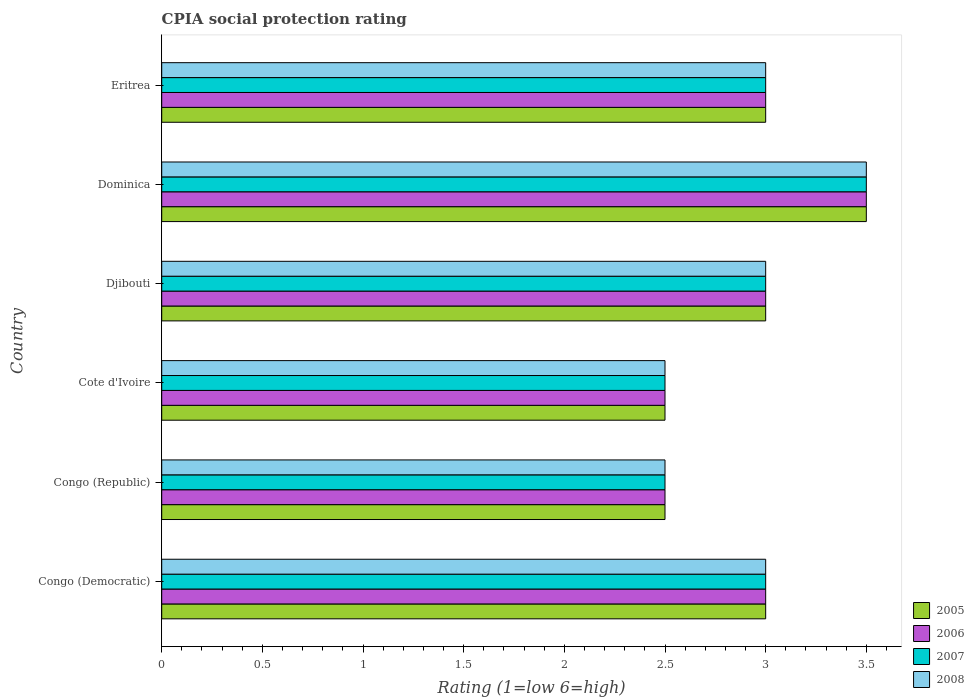How many different coloured bars are there?
Offer a terse response. 4. How many groups of bars are there?
Provide a short and direct response. 6. How many bars are there on the 1st tick from the top?
Your answer should be compact. 4. What is the label of the 1st group of bars from the top?
Provide a succinct answer. Eritrea. Across all countries, what is the maximum CPIA rating in 2008?
Offer a very short reply. 3.5. In which country was the CPIA rating in 2006 maximum?
Provide a short and direct response. Dominica. In which country was the CPIA rating in 2006 minimum?
Offer a very short reply. Congo (Republic). What is the total CPIA rating in 2005 in the graph?
Keep it short and to the point. 17.5. What is the difference between the CPIA rating in 2007 in Cote d'Ivoire and that in Eritrea?
Offer a very short reply. -0.5. What is the difference between the CPIA rating in 2006 in Dominica and the CPIA rating in 2008 in Congo (Republic)?
Keep it short and to the point. 1. What is the average CPIA rating in 2008 per country?
Provide a short and direct response. 2.92. What is the ratio of the CPIA rating in 2008 in Cote d'Ivoire to that in Djibouti?
Offer a terse response. 0.83. Is the CPIA rating in 2005 in Congo (Democratic) less than that in Cote d'Ivoire?
Give a very brief answer. No. What is the difference between the highest and the second highest CPIA rating in 2006?
Make the answer very short. 0.5. What is the difference between the highest and the lowest CPIA rating in 2006?
Your response must be concise. 1. In how many countries, is the CPIA rating in 2006 greater than the average CPIA rating in 2006 taken over all countries?
Your answer should be compact. 4. Is the sum of the CPIA rating in 2007 in Congo (Republic) and Eritrea greater than the maximum CPIA rating in 2006 across all countries?
Provide a succinct answer. Yes. What does the 1st bar from the top in Djibouti represents?
Provide a short and direct response. 2008. What does the 4th bar from the bottom in Cote d'Ivoire represents?
Keep it short and to the point. 2008. Is it the case that in every country, the sum of the CPIA rating in 2007 and CPIA rating in 2008 is greater than the CPIA rating in 2005?
Give a very brief answer. Yes. Are all the bars in the graph horizontal?
Provide a short and direct response. Yes. How many countries are there in the graph?
Offer a very short reply. 6. What is the difference between two consecutive major ticks on the X-axis?
Give a very brief answer. 0.5. Are the values on the major ticks of X-axis written in scientific E-notation?
Make the answer very short. No. Does the graph contain any zero values?
Provide a succinct answer. No. What is the title of the graph?
Give a very brief answer. CPIA social protection rating. What is the label or title of the X-axis?
Keep it short and to the point. Rating (1=low 6=high). What is the Rating (1=low 6=high) of 2006 in Congo (Democratic)?
Offer a terse response. 3. What is the Rating (1=low 6=high) in 2005 in Congo (Republic)?
Ensure brevity in your answer.  2.5. What is the Rating (1=low 6=high) of 2005 in Cote d'Ivoire?
Provide a short and direct response. 2.5. What is the Rating (1=low 6=high) of 2006 in Cote d'Ivoire?
Keep it short and to the point. 2.5. What is the Rating (1=low 6=high) of 2008 in Cote d'Ivoire?
Your response must be concise. 2.5. What is the Rating (1=low 6=high) in 2006 in Djibouti?
Give a very brief answer. 3. What is the Rating (1=low 6=high) in 2005 in Dominica?
Give a very brief answer. 3.5. What is the Rating (1=low 6=high) in 2008 in Dominica?
Provide a succinct answer. 3.5. What is the Rating (1=low 6=high) of 2006 in Eritrea?
Give a very brief answer. 3. What is the Rating (1=low 6=high) of 2007 in Eritrea?
Provide a short and direct response. 3. What is the Rating (1=low 6=high) in 2008 in Eritrea?
Ensure brevity in your answer.  3. Across all countries, what is the maximum Rating (1=low 6=high) of 2005?
Provide a succinct answer. 3.5. Across all countries, what is the maximum Rating (1=low 6=high) of 2006?
Offer a very short reply. 3.5. Across all countries, what is the maximum Rating (1=low 6=high) in 2007?
Keep it short and to the point. 3.5. Across all countries, what is the minimum Rating (1=low 6=high) of 2007?
Provide a succinct answer. 2.5. Across all countries, what is the minimum Rating (1=low 6=high) in 2008?
Offer a very short reply. 2.5. What is the total Rating (1=low 6=high) of 2005 in the graph?
Give a very brief answer. 17.5. What is the total Rating (1=low 6=high) in 2006 in the graph?
Keep it short and to the point. 17.5. What is the total Rating (1=low 6=high) in 2007 in the graph?
Provide a succinct answer. 17.5. What is the total Rating (1=low 6=high) of 2008 in the graph?
Give a very brief answer. 17.5. What is the difference between the Rating (1=low 6=high) in 2005 in Congo (Democratic) and that in Congo (Republic)?
Your answer should be very brief. 0.5. What is the difference between the Rating (1=low 6=high) in 2007 in Congo (Democratic) and that in Congo (Republic)?
Provide a succinct answer. 0.5. What is the difference between the Rating (1=low 6=high) in 2005 in Congo (Democratic) and that in Cote d'Ivoire?
Your answer should be compact. 0.5. What is the difference between the Rating (1=low 6=high) of 2006 in Congo (Democratic) and that in Djibouti?
Give a very brief answer. 0. What is the difference between the Rating (1=low 6=high) of 2007 in Congo (Democratic) and that in Djibouti?
Offer a terse response. 0. What is the difference between the Rating (1=low 6=high) of 2008 in Congo (Democratic) and that in Djibouti?
Provide a succinct answer. 0. What is the difference between the Rating (1=low 6=high) in 2005 in Congo (Democratic) and that in Dominica?
Ensure brevity in your answer.  -0.5. What is the difference between the Rating (1=low 6=high) of 2007 in Congo (Democratic) and that in Dominica?
Make the answer very short. -0.5. What is the difference between the Rating (1=low 6=high) in 2008 in Congo (Democratic) and that in Dominica?
Offer a very short reply. -0.5. What is the difference between the Rating (1=low 6=high) in 2008 in Congo (Democratic) and that in Eritrea?
Keep it short and to the point. 0. What is the difference between the Rating (1=low 6=high) of 2005 in Congo (Republic) and that in Cote d'Ivoire?
Provide a succinct answer. 0. What is the difference between the Rating (1=low 6=high) of 2007 in Congo (Republic) and that in Cote d'Ivoire?
Offer a terse response. 0. What is the difference between the Rating (1=low 6=high) in 2008 in Congo (Republic) and that in Cote d'Ivoire?
Provide a succinct answer. 0. What is the difference between the Rating (1=low 6=high) of 2005 in Congo (Republic) and that in Djibouti?
Your response must be concise. -0.5. What is the difference between the Rating (1=low 6=high) in 2006 in Congo (Republic) and that in Djibouti?
Your answer should be very brief. -0.5. What is the difference between the Rating (1=low 6=high) in 2007 in Congo (Republic) and that in Djibouti?
Make the answer very short. -0.5. What is the difference between the Rating (1=low 6=high) of 2008 in Congo (Republic) and that in Djibouti?
Offer a terse response. -0.5. What is the difference between the Rating (1=low 6=high) in 2006 in Congo (Republic) and that in Dominica?
Make the answer very short. -1. What is the difference between the Rating (1=low 6=high) of 2008 in Congo (Republic) and that in Dominica?
Provide a succinct answer. -1. What is the difference between the Rating (1=low 6=high) in 2006 in Congo (Republic) and that in Eritrea?
Ensure brevity in your answer.  -0.5. What is the difference between the Rating (1=low 6=high) of 2007 in Congo (Republic) and that in Eritrea?
Offer a very short reply. -0.5. What is the difference between the Rating (1=low 6=high) in 2008 in Congo (Republic) and that in Eritrea?
Your response must be concise. -0.5. What is the difference between the Rating (1=low 6=high) in 2005 in Cote d'Ivoire and that in Djibouti?
Keep it short and to the point. -0.5. What is the difference between the Rating (1=low 6=high) of 2008 in Cote d'Ivoire and that in Djibouti?
Offer a terse response. -0.5. What is the difference between the Rating (1=low 6=high) of 2007 in Cote d'Ivoire and that in Dominica?
Your response must be concise. -1. What is the difference between the Rating (1=low 6=high) of 2008 in Cote d'Ivoire and that in Dominica?
Your answer should be compact. -1. What is the difference between the Rating (1=low 6=high) of 2005 in Djibouti and that in Dominica?
Offer a terse response. -0.5. What is the difference between the Rating (1=low 6=high) in 2006 in Djibouti and that in Dominica?
Provide a short and direct response. -0.5. What is the difference between the Rating (1=low 6=high) in 2007 in Djibouti and that in Dominica?
Offer a terse response. -0.5. What is the difference between the Rating (1=low 6=high) in 2005 in Djibouti and that in Eritrea?
Provide a short and direct response. 0. What is the difference between the Rating (1=low 6=high) of 2006 in Djibouti and that in Eritrea?
Give a very brief answer. 0. What is the difference between the Rating (1=low 6=high) in 2007 in Djibouti and that in Eritrea?
Your response must be concise. 0. What is the difference between the Rating (1=low 6=high) of 2008 in Djibouti and that in Eritrea?
Your answer should be very brief. 0. What is the difference between the Rating (1=low 6=high) of 2005 in Dominica and that in Eritrea?
Your answer should be very brief. 0.5. What is the difference between the Rating (1=low 6=high) in 2006 in Dominica and that in Eritrea?
Ensure brevity in your answer.  0.5. What is the difference between the Rating (1=low 6=high) in 2007 in Dominica and that in Eritrea?
Ensure brevity in your answer.  0.5. What is the difference between the Rating (1=low 6=high) of 2005 in Congo (Democratic) and the Rating (1=low 6=high) of 2006 in Congo (Republic)?
Ensure brevity in your answer.  0.5. What is the difference between the Rating (1=low 6=high) of 2005 in Congo (Democratic) and the Rating (1=low 6=high) of 2007 in Congo (Republic)?
Ensure brevity in your answer.  0.5. What is the difference between the Rating (1=low 6=high) of 2005 in Congo (Democratic) and the Rating (1=low 6=high) of 2008 in Congo (Republic)?
Offer a very short reply. 0.5. What is the difference between the Rating (1=low 6=high) in 2006 in Congo (Democratic) and the Rating (1=low 6=high) in 2008 in Congo (Republic)?
Provide a short and direct response. 0.5. What is the difference between the Rating (1=low 6=high) of 2007 in Congo (Democratic) and the Rating (1=low 6=high) of 2008 in Congo (Republic)?
Make the answer very short. 0.5. What is the difference between the Rating (1=low 6=high) of 2005 in Congo (Democratic) and the Rating (1=low 6=high) of 2007 in Cote d'Ivoire?
Your answer should be very brief. 0.5. What is the difference between the Rating (1=low 6=high) in 2005 in Congo (Democratic) and the Rating (1=low 6=high) in 2008 in Cote d'Ivoire?
Offer a terse response. 0.5. What is the difference between the Rating (1=low 6=high) in 2006 in Congo (Democratic) and the Rating (1=low 6=high) in 2007 in Cote d'Ivoire?
Your answer should be compact. 0.5. What is the difference between the Rating (1=low 6=high) in 2006 in Congo (Democratic) and the Rating (1=low 6=high) in 2008 in Cote d'Ivoire?
Your answer should be very brief. 0.5. What is the difference between the Rating (1=low 6=high) of 2005 in Congo (Democratic) and the Rating (1=low 6=high) of 2006 in Djibouti?
Keep it short and to the point. 0. What is the difference between the Rating (1=low 6=high) in 2005 in Congo (Democratic) and the Rating (1=low 6=high) in 2007 in Djibouti?
Your answer should be very brief. 0. What is the difference between the Rating (1=low 6=high) in 2006 in Congo (Democratic) and the Rating (1=low 6=high) in 2007 in Djibouti?
Provide a succinct answer. 0. What is the difference between the Rating (1=low 6=high) in 2007 in Congo (Democratic) and the Rating (1=low 6=high) in 2008 in Dominica?
Provide a short and direct response. -0.5. What is the difference between the Rating (1=low 6=high) of 2005 in Congo (Democratic) and the Rating (1=low 6=high) of 2007 in Eritrea?
Your response must be concise. 0. What is the difference between the Rating (1=low 6=high) of 2005 in Congo (Republic) and the Rating (1=low 6=high) of 2007 in Cote d'Ivoire?
Ensure brevity in your answer.  0. What is the difference between the Rating (1=low 6=high) of 2006 in Congo (Republic) and the Rating (1=low 6=high) of 2007 in Cote d'Ivoire?
Keep it short and to the point. 0. What is the difference between the Rating (1=low 6=high) of 2006 in Congo (Republic) and the Rating (1=low 6=high) of 2008 in Cote d'Ivoire?
Offer a terse response. 0. What is the difference between the Rating (1=low 6=high) in 2005 in Congo (Republic) and the Rating (1=low 6=high) in 2006 in Djibouti?
Your answer should be very brief. -0.5. What is the difference between the Rating (1=low 6=high) in 2005 in Congo (Republic) and the Rating (1=low 6=high) in 2007 in Djibouti?
Offer a terse response. -0.5. What is the difference between the Rating (1=low 6=high) in 2006 in Congo (Republic) and the Rating (1=low 6=high) in 2008 in Djibouti?
Provide a succinct answer. -0.5. What is the difference between the Rating (1=low 6=high) of 2005 in Congo (Republic) and the Rating (1=low 6=high) of 2006 in Dominica?
Ensure brevity in your answer.  -1. What is the difference between the Rating (1=low 6=high) in 2005 in Congo (Republic) and the Rating (1=low 6=high) in 2007 in Dominica?
Provide a short and direct response. -1. What is the difference between the Rating (1=low 6=high) in 2005 in Congo (Republic) and the Rating (1=low 6=high) in 2008 in Dominica?
Provide a succinct answer. -1. What is the difference between the Rating (1=low 6=high) in 2006 in Congo (Republic) and the Rating (1=low 6=high) in 2007 in Dominica?
Your answer should be compact. -1. What is the difference between the Rating (1=low 6=high) in 2006 in Congo (Republic) and the Rating (1=low 6=high) in 2008 in Dominica?
Provide a short and direct response. -1. What is the difference between the Rating (1=low 6=high) of 2007 in Congo (Republic) and the Rating (1=low 6=high) of 2008 in Dominica?
Your answer should be very brief. -1. What is the difference between the Rating (1=low 6=high) of 2005 in Congo (Republic) and the Rating (1=low 6=high) of 2006 in Eritrea?
Your response must be concise. -0.5. What is the difference between the Rating (1=low 6=high) in 2005 in Congo (Republic) and the Rating (1=low 6=high) in 2008 in Eritrea?
Give a very brief answer. -0.5. What is the difference between the Rating (1=low 6=high) of 2006 in Congo (Republic) and the Rating (1=low 6=high) of 2008 in Eritrea?
Ensure brevity in your answer.  -0.5. What is the difference between the Rating (1=low 6=high) of 2007 in Congo (Republic) and the Rating (1=low 6=high) of 2008 in Eritrea?
Provide a short and direct response. -0.5. What is the difference between the Rating (1=low 6=high) in 2005 in Cote d'Ivoire and the Rating (1=low 6=high) in 2007 in Djibouti?
Your answer should be compact. -0.5. What is the difference between the Rating (1=low 6=high) of 2007 in Cote d'Ivoire and the Rating (1=low 6=high) of 2008 in Djibouti?
Your answer should be very brief. -0.5. What is the difference between the Rating (1=low 6=high) of 2005 in Cote d'Ivoire and the Rating (1=low 6=high) of 2006 in Dominica?
Provide a short and direct response. -1. What is the difference between the Rating (1=low 6=high) in 2005 in Cote d'Ivoire and the Rating (1=low 6=high) in 2007 in Dominica?
Offer a very short reply. -1. What is the difference between the Rating (1=low 6=high) of 2006 in Cote d'Ivoire and the Rating (1=low 6=high) of 2007 in Dominica?
Offer a terse response. -1. What is the difference between the Rating (1=low 6=high) in 2006 in Cote d'Ivoire and the Rating (1=low 6=high) in 2008 in Dominica?
Provide a succinct answer. -1. What is the difference between the Rating (1=low 6=high) in 2005 in Cote d'Ivoire and the Rating (1=low 6=high) in 2006 in Eritrea?
Your answer should be compact. -0.5. What is the difference between the Rating (1=low 6=high) of 2005 in Cote d'Ivoire and the Rating (1=low 6=high) of 2007 in Eritrea?
Provide a succinct answer. -0.5. What is the difference between the Rating (1=low 6=high) of 2006 in Cote d'Ivoire and the Rating (1=low 6=high) of 2007 in Eritrea?
Your answer should be very brief. -0.5. What is the difference between the Rating (1=low 6=high) in 2006 in Cote d'Ivoire and the Rating (1=low 6=high) in 2008 in Eritrea?
Your answer should be very brief. -0.5. What is the difference between the Rating (1=low 6=high) in 2005 in Djibouti and the Rating (1=low 6=high) in 2006 in Dominica?
Keep it short and to the point. -0.5. What is the difference between the Rating (1=low 6=high) in 2006 in Djibouti and the Rating (1=low 6=high) in 2007 in Dominica?
Your response must be concise. -0.5. What is the difference between the Rating (1=low 6=high) in 2005 in Djibouti and the Rating (1=low 6=high) in 2006 in Eritrea?
Your response must be concise. 0. What is the difference between the Rating (1=low 6=high) in 2005 in Djibouti and the Rating (1=low 6=high) in 2007 in Eritrea?
Offer a very short reply. 0. What is the difference between the Rating (1=low 6=high) of 2005 in Dominica and the Rating (1=low 6=high) of 2008 in Eritrea?
Make the answer very short. 0.5. What is the difference between the Rating (1=low 6=high) in 2006 in Dominica and the Rating (1=low 6=high) in 2007 in Eritrea?
Your answer should be compact. 0.5. What is the difference between the Rating (1=low 6=high) of 2006 in Dominica and the Rating (1=low 6=high) of 2008 in Eritrea?
Provide a short and direct response. 0.5. What is the difference between the Rating (1=low 6=high) in 2007 in Dominica and the Rating (1=low 6=high) in 2008 in Eritrea?
Give a very brief answer. 0.5. What is the average Rating (1=low 6=high) of 2005 per country?
Give a very brief answer. 2.92. What is the average Rating (1=low 6=high) in 2006 per country?
Offer a terse response. 2.92. What is the average Rating (1=low 6=high) in 2007 per country?
Make the answer very short. 2.92. What is the average Rating (1=low 6=high) in 2008 per country?
Keep it short and to the point. 2.92. What is the difference between the Rating (1=low 6=high) in 2006 and Rating (1=low 6=high) in 2007 in Congo (Democratic)?
Your response must be concise. 0. What is the difference between the Rating (1=low 6=high) in 2007 and Rating (1=low 6=high) in 2008 in Congo (Democratic)?
Keep it short and to the point. 0. What is the difference between the Rating (1=low 6=high) in 2005 and Rating (1=low 6=high) in 2006 in Congo (Republic)?
Keep it short and to the point. 0. What is the difference between the Rating (1=low 6=high) in 2005 and Rating (1=low 6=high) in 2008 in Congo (Republic)?
Your answer should be compact. 0. What is the difference between the Rating (1=low 6=high) of 2006 and Rating (1=low 6=high) of 2007 in Congo (Republic)?
Provide a succinct answer. 0. What is the difference between the Rating (1=low 6=high) in 2005 and Rating (1=low 6=high) in 2006 in Cote d'Ivoire?
Your answer should be very brief. 0. What is the difference between the Rating (1=low 6=high) of 2005 and Rating (1=low 6=high) of 2007 in Cote d'Ivoire?
Make the answer very short. 0. What is the difference between the Rating (1=low 6=high) in 2007 and Rating (1=low 6=high) in 2008 in Cote d'Ivoire?
Offer a terse response. 0. What is the difference between the Rating (1=low 6=high) in 2005 and Rating (1=low 6=high) in 2008 in Djibouti?
Keep it short and to the point. 0. What is the difference between the Rating (1=low 6=high) in 2006 and Rating (1=low 6=high) in 2007 in Djibouti?
Your response must be concise. 0. What is the difference between the Rating (1=low 6=high) in 2006 and Rating (1=low 6=high) in 2007 in Dominica?
Make the answer very short. 0. What is the difference between the Rating (1=low 6=high) in 2007 and Rating (1=low 6=high) in 2008 in Dominica?
Keep it short and to the point. 0. What is the difference between the Rating (1=low 6=high) in 2005 and Rating (1=low 6=high) in 2007 in Eritrea?
Ensure brevity in your answer.  0. What is the difference between the Rating (1=low 6=high) in 2007 and Rating (1=low 6=high) in 2008 in Eritrea?
Provide a succinct answer. 0. What is the ratio of the Rating (1=low 6=high) of 2005 in Congo (Democratic) to that in Congo (Republic)?
Provide a succinct answer. 1.2. What is the ratio of the Rating (1=low 6=high) of 2006 in Congo (Democratic) to that in Congo (Republic)?
Provide a succinct answer. 1.2. What is the ratio of the Rating (1=low 6=high) of 2008 in Congo (Democratic) to that in Cote d'Ivoire?
Your answer should be very brief. 1.2. What is the ratio of the Rating (1=low 6=high) of 2007 in Congo (Democratic) to that in Djibouti?
Provide a succinct answer. 1. What is the ratio of the Rating (1=low 6=high) in 2006 in Congo (Democratic) to that in Dominica?
Make the answer very short. 0.86. What is the ratio of the Rating (1=low 6=high) of 2007 in Congo (Democratic) to that in Dominica?
Keep it short and to the point. 0.86. What is the ratio of the Rating (1=low 6=high) of 2008 in Congo (Democratic) to that in Dominica?
Offer a terse response. 0.86. What is the ratio of the Rating (1=low 6=high) of 2005 in Congo (Democratic) to that in Eritrea?
Keep it short and to the point. 1. What is the ratio of the Rating (1=low 6=high) in 2006 in Congo (Democratic) to that in Eritrea?
Ensure brevity in your answer.  1. What is the ratio of the Rating (1=low 6=high) in 2008 in Congo (Democratic) to that in Eritrea?
Keep it short and to the point. 1. What is the ratio of the Rating (1=low 6=high) in 2006 in Congo (Republic) to that in Cote d'Ivoire?
Your response must be concise. 1. What is the ratio of the Rating (1=low 6=high) of 2007 in Congo (Republic) to that in Cote d'Ivoire?
Your response must be concise. 1. What is the ratio of the Rating (1=low 6=high) in 2005 in Congo (Republic) to that in Djibouti?
Your response must be concise. 0.83. What is the ratio of the Rating (1=low 6=high) of 2006 in Congo (Republic) to that in Djibouti?
Give a very brief answer. 0.83. What is the ratio of the Rating (1=low 6=high) in 2007 in Congo (Republic) to that in Djibouti?
Give a very brief answer. 0.83. What is the ratio of the Rating (1=low 6=high) in 2005 in Congo (Republic) to that in Dominica?
Your answer should be very brief. 0.71. What is the ratio of the Rating (1=low 6=high) of 2005 in Congo (Republic) to that in Eritrea?
Provide a succinct answer. 0.83. What is the ratio of the Rating (1=low 6=high) in 2008 in Congo (Republic) to that in Eritrea?
Provide a succinct answer. 0.83. What is the ratio of the Rating (1=low 6=high) of 2007 in Cote d'Ivoire to that in Djibouti?
Ensure brevity in your answer.  0.83. What is the ratio of the Rating (1=low 6=high) of 2005 in Cote d'Ivoire to that in Dominica?
Your response must be concise. 0.71. What is the ratio of the Rating (1=low 6=high) of 2006 in Cote d'Ivoire to that in Dominica?
Ensure brevity in your answer.  0.71. What is the ratio of the Rating (1=low 6=high) of 2007 in Cote d'Ivoire to that in Dominica?
Your answer should be very brief. 0.71. What is the ratio of the Rating (1=low 6=high) of 2008 in Cote d'Ivoire to that in Dominica?
Keep it short and to the point. 0.71. What is the ratio of the Rating (1=low 6=high) of 2006 in Cote d'Ivoire to that in Eritrea?
Give a very brief answer. 0.83. What is the ratio of the Rating (1=low 6=high) in 2007 in Cote d'Ivoire to that in Eritrea?
Offer a very short reply. 0.83. What is the ratio of the Rating (1=low 6=high) of 2005 in Djibouti to that in Dominica?
Provide a short and direct response. 0.86. What is the ratio of the Rating (1=low 6=high) of 2006 in Djibouti to that in Dominica?
Offer a terse response. 0.86. What is the ratio of the Rating (1=low 6=high) of 2007 in Djibouti to that in Dominica?
Make the answer very short. 0.86. What is the ratio of the Rating (1=low 6=high) of 2008 in Djibouti to that in Dominica?
Provide a short and direct response. 0.86. What is the ratio of the Rating (1=low 6=high) of 2005 in Djibouti to that in Eritrea?
Provide a succinct answer. 1. What is the ratio of the Rating (1=low 6=high) of 2006 in Djibouti to that in Eritrea?
Your response must be concise. 1. What is the ratio of the Rating (1=low 6=high) of 2007 in Djibouti to that in Eritrea?
Provide a short and direct response. 1. What is the ratio of the Rating (1=low 6=high) of 2005 in Dominica to that in Eritrea?
Provide a short and direct response. 1.17. What is the ratio of the Rating (1=low 6=high) of 2007 in Dominica to that in Eritrea?
Keep it short and to the point. 1.17. What is the difference between the highest and the second highest Rating (1=low 6=high) of 2005?
Your answer should be very brief. 0.5. What is the difference between the highest and the second highest Rating (1=low 6=high) in 2008?
Give a very brief answer. 0.5. What is the difference between the highest and the lowest Rating (1=low 6=high) in 2005?
Offer a terse response. 1. What is the difference between the highest and the lowest Rating (1=low 6=high) in 2007?
Provide a succinct answer. 1. What is the difference between the highest and the lowest Rating (1=low 6=high) of 2008?
Give a very brief answer. 1. 